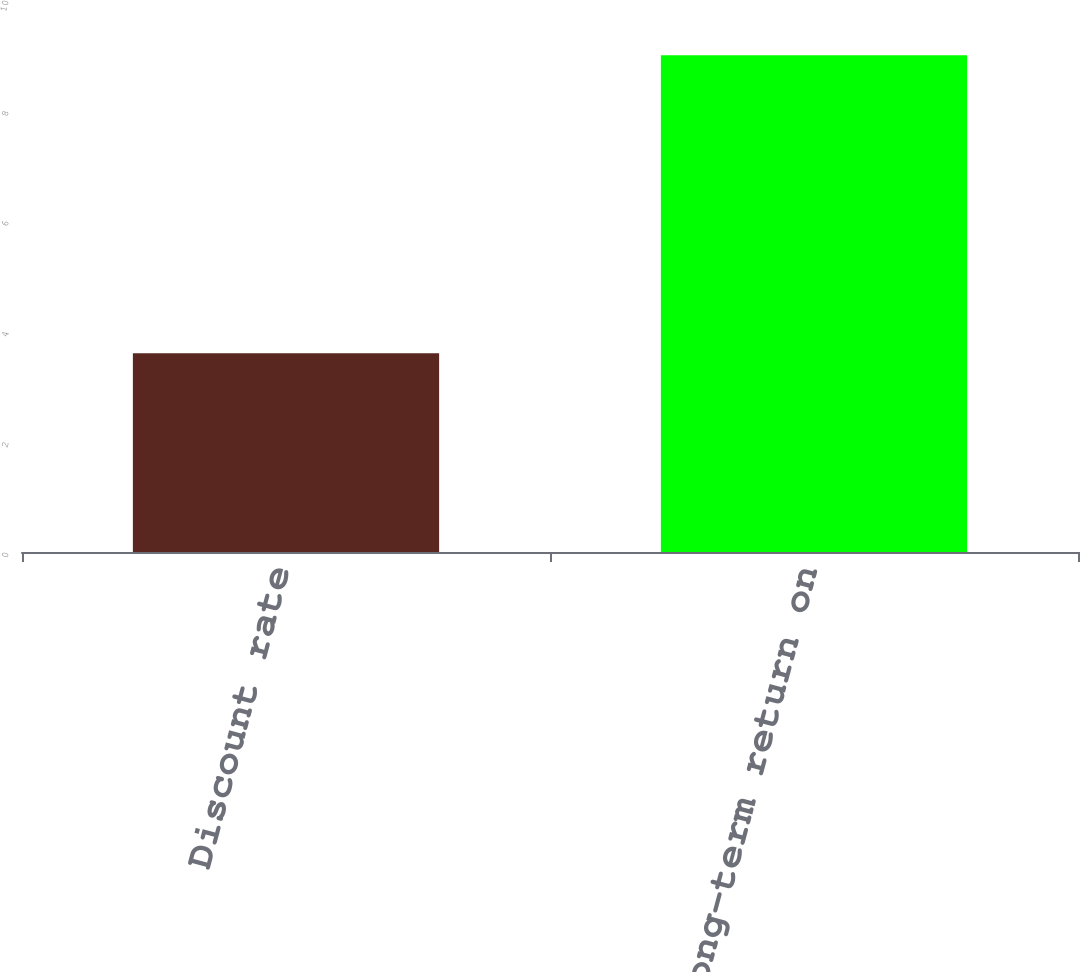Convert chart to OTSL. <chart><loc_0><loc_0><loc_500><loc_500><bar_chart><fcel>Discount rate<fcel>Expected long-term return on<nl><fcel>3.6<fcel>9<nl></chart> 